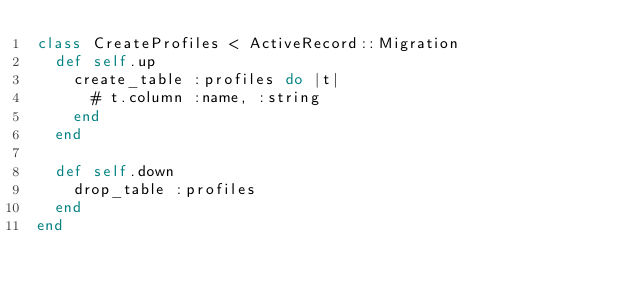Convert code to text. <code><loc_0><loc_0><loc_500><loc_500><_Ruby_>class CreateProfiles < ActiveRecord::Migration
  def self.up
    create_table :profiles do |t|
      # t.column :name, :string
    end
  end

  def self.down
    drop_table :profiles
  end
end
</code> 